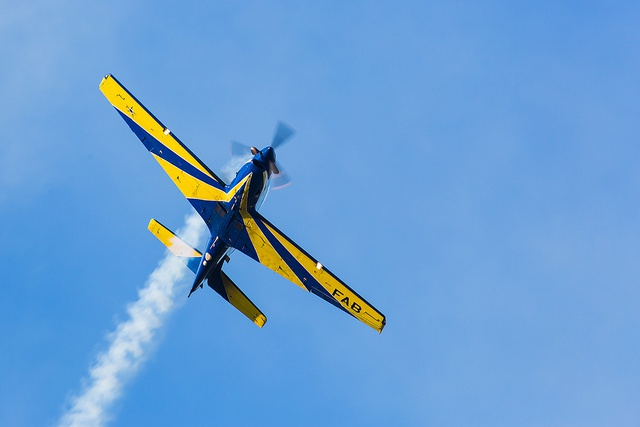Describe the objects in this image and their specific colors. I can see a airplane in lightblue, navy, black, gold, and orange tones in this image. 